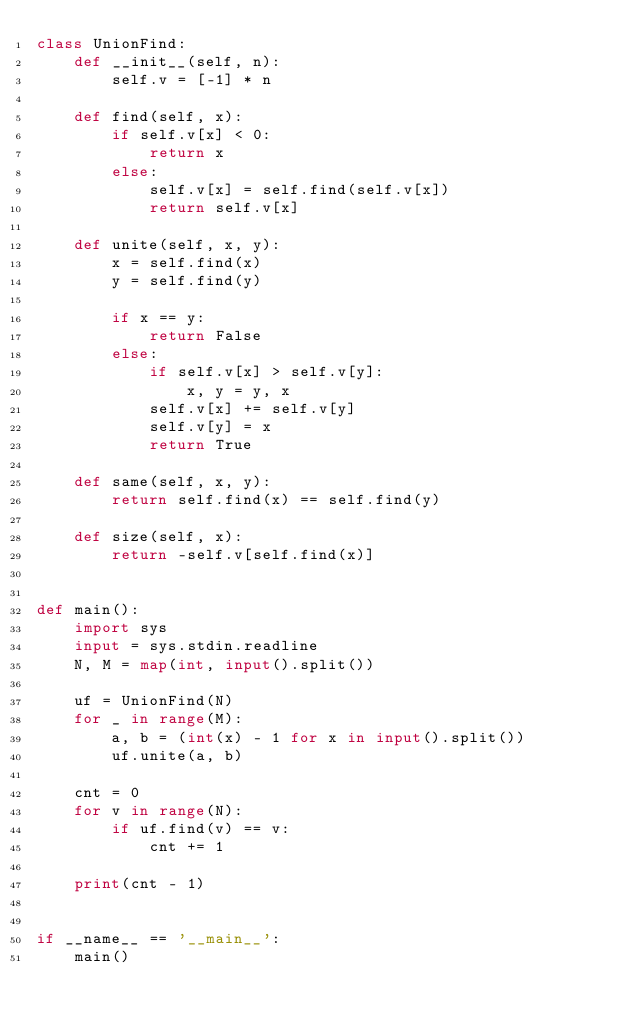Convert code to text. <code><loc_0><loc_0><loc_500><loc_500><_Python_>class UnionFind:
    def __init__(self, n):
        self.v = [-1] * n

    def find(self, x):
        if self.v[x] < 0:
            return x
        else:
            self.v[x] = self.find(self.v[x])
            return self.v[x]

    def unite(self, x, y):
        x = self.find(x)
        y = self.find(y)

        if x == y:
            return False
        else:
            if self.v[x] > self.v[y]:
                x, y = y, x
            self.v[x] += self.v[y]
            self.v[y] = x
            return True

    def same(self, x, y):
        return self.find(x) == self.find(y)

    def size(self, x):
        return -self.v[self.find(x)]


def main():
    import sys
    input = sys.stdin.readline
    N, M = map(int, input().split())

    uf = UnionFind(N)
    for _ in range(M):
        a, b = (int(x) - 1 for x in input().split())
        uf.unite(a, b)

    cnt = 0
    for v in range(N):
        if uf.find(v) == v:
            cnt += 1

    print(cnt - 1)


if __name__ == '__main__':
    main()
</code> 